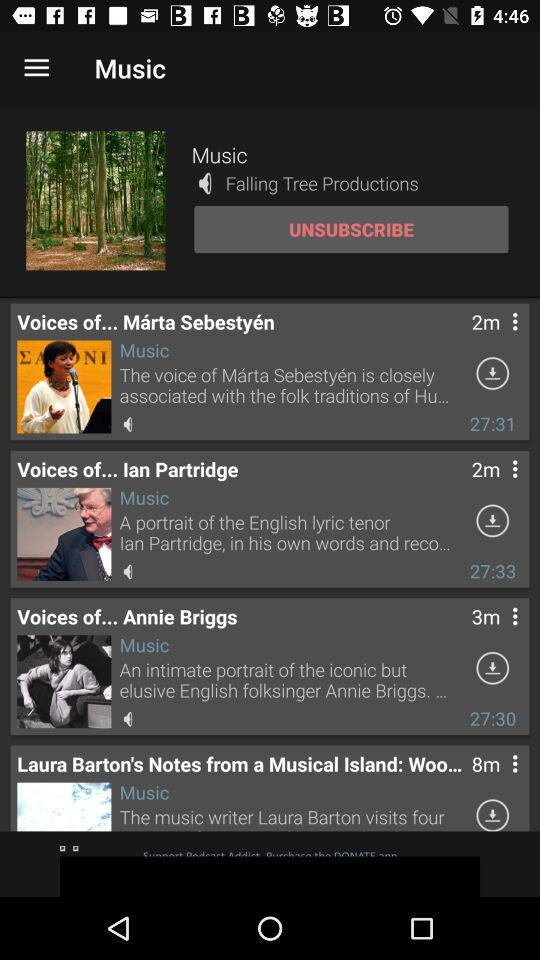What is the duration of the "Voices of... Marta Sebestyen" music? The duration of the "Voices of... Marta Sebestyen" music is 27:31. 